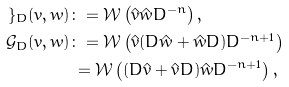Convert formula to latex. <formula><loc_0><loc_0><loc_500><loc_500>\mathcal { g } _ { D } ( v , w ) & \colon = \mathcal { W } \left ( \hat { v } \hat { w } D ^ { - n } \right ) , \\ \mathcal { G } _ { D } ( v , w ) & \colon = \mathcal { W } \left ( \hat { v } ( D \hat { w } + \hat { w } D ) D ^ { - n + 1 } \right ) \\ & \, = \mathcal { W } \left ( ( D \hat { v } + \hat { v } D ) \hat { w } D ^ { - n + 1 } \right ) ,</formula> 